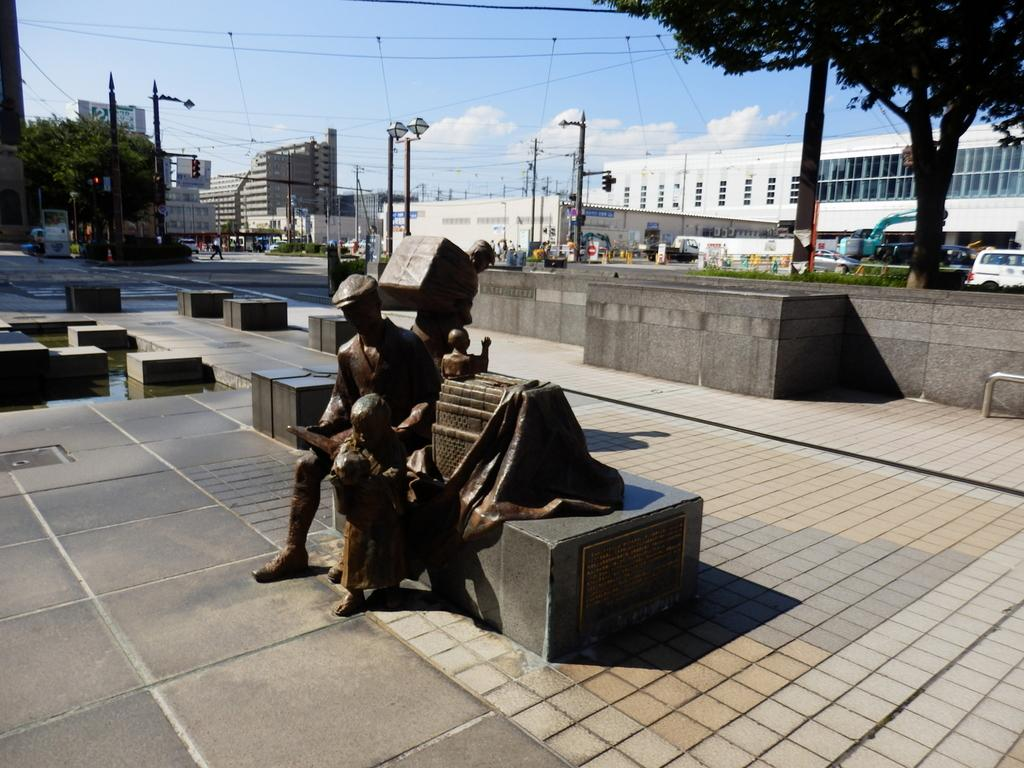What type of objects can be seen in the image? There are statues, black color objects, trees, buildings, light poles, traffic lights, and vehicles in the image. Can you describe the natural elements in the image? There are trees and the sky visible in the image, with clouds present in the sky. What type of man-made structures are present in the image? There are buildings, light poles, and traffic lights in the image. Are there any transportation-related objects in the image? Yes, there are vehicles in the image. Where is the store located in the image? There is no store present in the image. What type of list can be seen in the image? There is no list present in the image. Can you tell me where the faucet is located in the image? There is no faucet present in the image. 